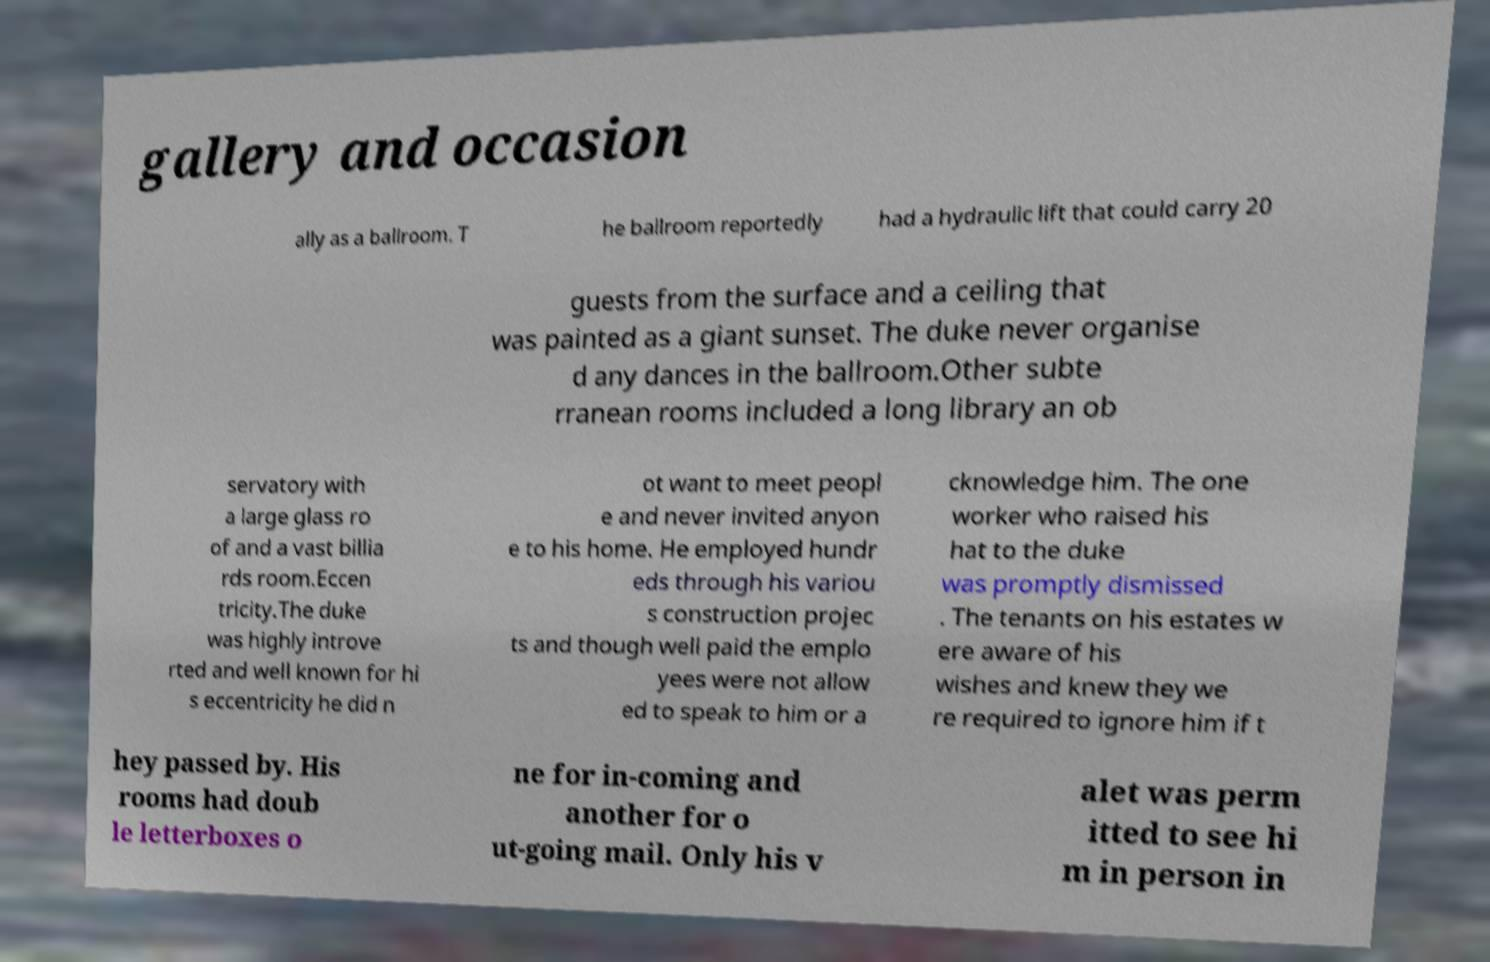Please read and relay the text visible in this image. What does it say? gallery and occasion ally as a ballroom. T he ballroom reportedly had a hydraulic lift that could carry 20 guests from the surface and a ceiling that was painted as a giant sunset. The duke never organise d any dances in the ballroom.Other subte rranean rooms included a long library an ob servatory with a large glass ro of and a vast billia rds room.Eccen tricity.The duke was highly introve rted and well known for hi s eccentricity he did n ot want to meet peopl e and never invited anyon e to his home. He employed hundr eds through his variou s construction projec ts and though well paid the emplo yees were not allow ed to speak to him or a cknowledge him. The one worker who raised his hat to the duke was promptly dismissed . The tenants on his estates w ere aware of his wishes and knew they we re required to ignore him if t hey passed by. His rooms had doub le letterboxes o ne for in-coming and another for o ut-going mail. Only his v alet was perm itted to see hi m in person in 